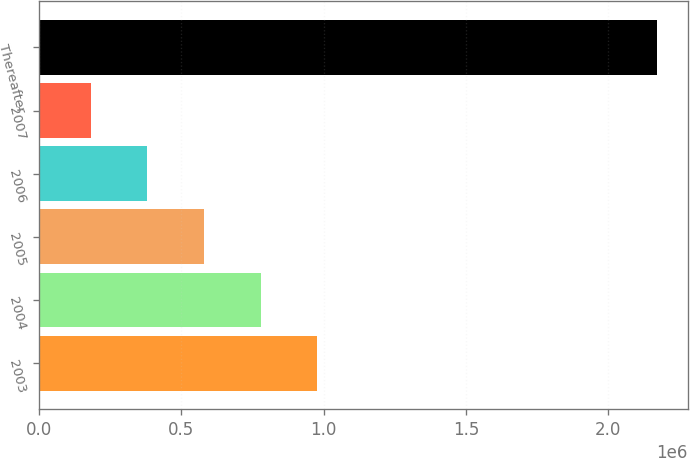<chart> <loc_0><loc_0><loc_500><loc_500><bar_chart><fcel>2003<fcel>2004<fcel>2005<fcel>2006<fcel>2007<fcel>Thereafter<nl><fcel>978096<fcel>779230<fcel>580364<fcel>381498<fcel>182632<fcel>2.17129e+06<nl></chart> 